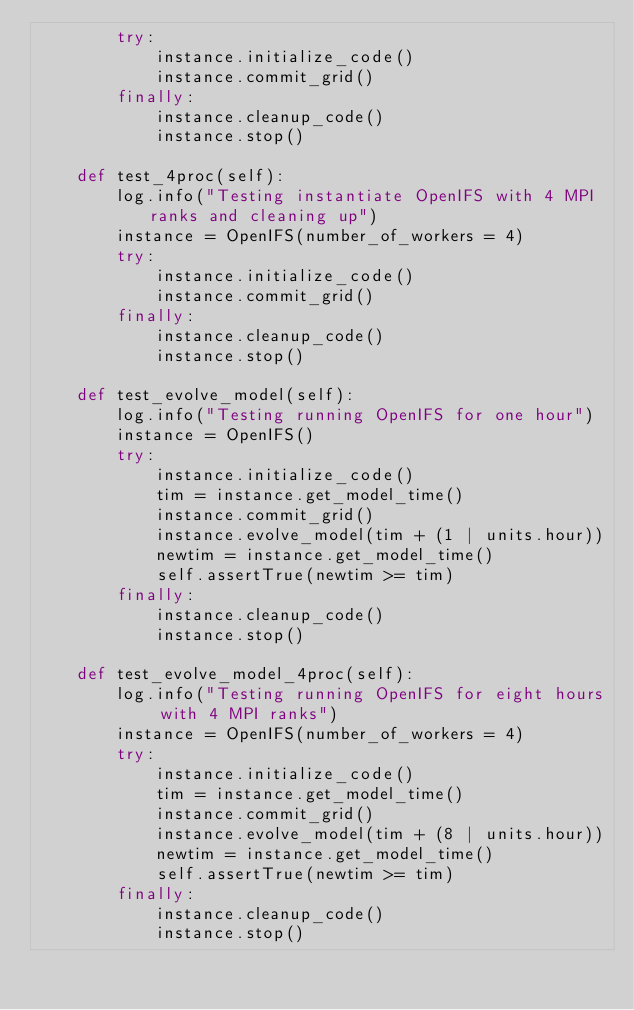<code> <loc_0><loc_0><loc_500><loc_500><_Python_>        try:
            instance.initialize_code()
            instance.commit_grid()
        finally:
            instance.cleanup_code()
            instance.stop()

    def test_4proc(self):
        log.info("Testing instantiate OpenIFS with 4 MPI ranks and cleaning up")
        instance = OpenIFS(number_of_workers = 4)
        try:
            instance.initialize_code()
            instance.commit_grid()
        finally:
            instance.cleanup_code()
            instance.stop()

    def test_evolve_model(self):
        log.info("Testing running OpenIFS for one hour")
        instance = OpenIFS()
        try:
            instance.initialize_code()
            tim = instance.get_model_time()
            instance.commit_grid()
            instance.evolve_model(tim + (1 | units.hour))
            newtim = instance.get_model_time()
            self.assertTrue(newtim >= tim)
        finally:
            instance.cleanup_code()
            instance.stop()

    def test_evolve_model_4proc(self):
        log.info("Testing running OpenIFS for eight hours with 4 MPI ranks")
        instance = OpenIFS(number_of_workers = 4)
        try:
            instance.initialize_code()
            tim = instance.get_model_time()
            instance.commit_grid()
            instance.evolve_model(tim + (8 | units.hour))
            newtim = instance.get_model_time()
            self.assertTrue(newtim >= tim)
        finally:
            instance.cleanup_code()
            instance.stop()
</code> 